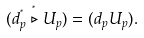Convert formula to latex. <formula><loc_0><loc_0><loc_500><loc_500>( d ^ { ^ { * } } _ { p } \stackrel { ^ { * } } { \triangleright } U _ { p } ) = ( d _ { p } U _ { p } ) .</formula> 